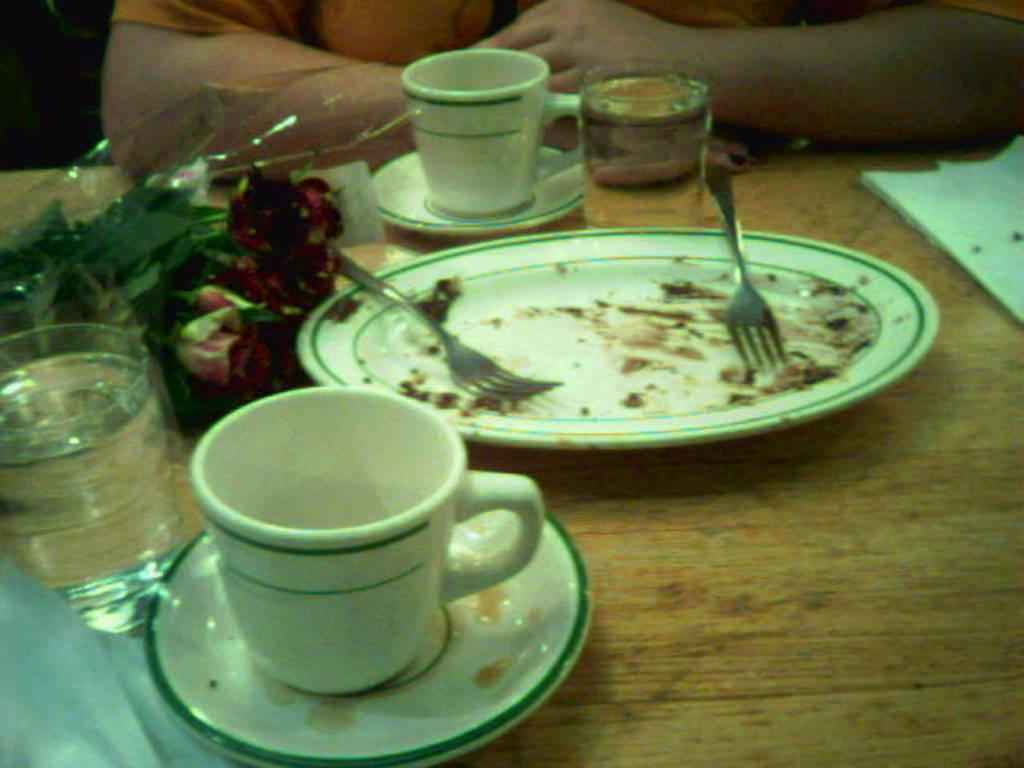What part of the human body can be seen in the image? A partial part of a human ear is visible in the image. What type of decoration is on the table in the image? There is a rose flower bouquet on the table. What type of beverage container is on the table? There is a glass of water on the table. What type of dishware is on the table? There are cups and saucers on the table. What type of dishware is on the empty plate? There are two forks on the empty plate. What type of stone is used to build the police station in the image? There is no police station or stone present in the image. 